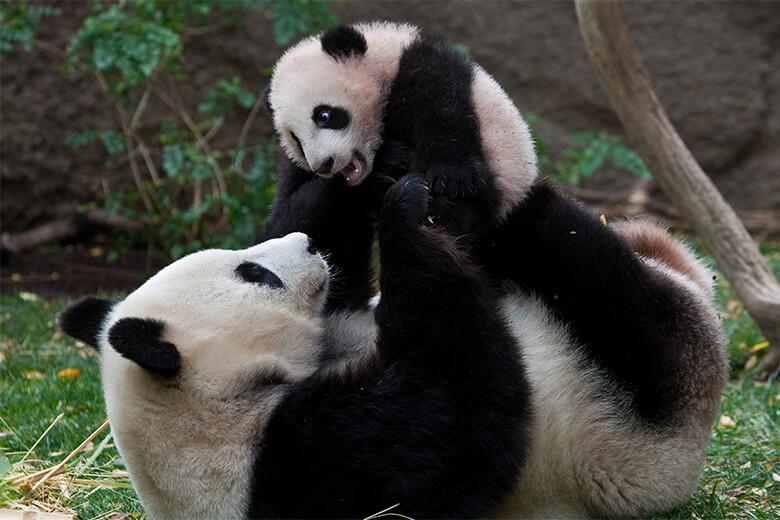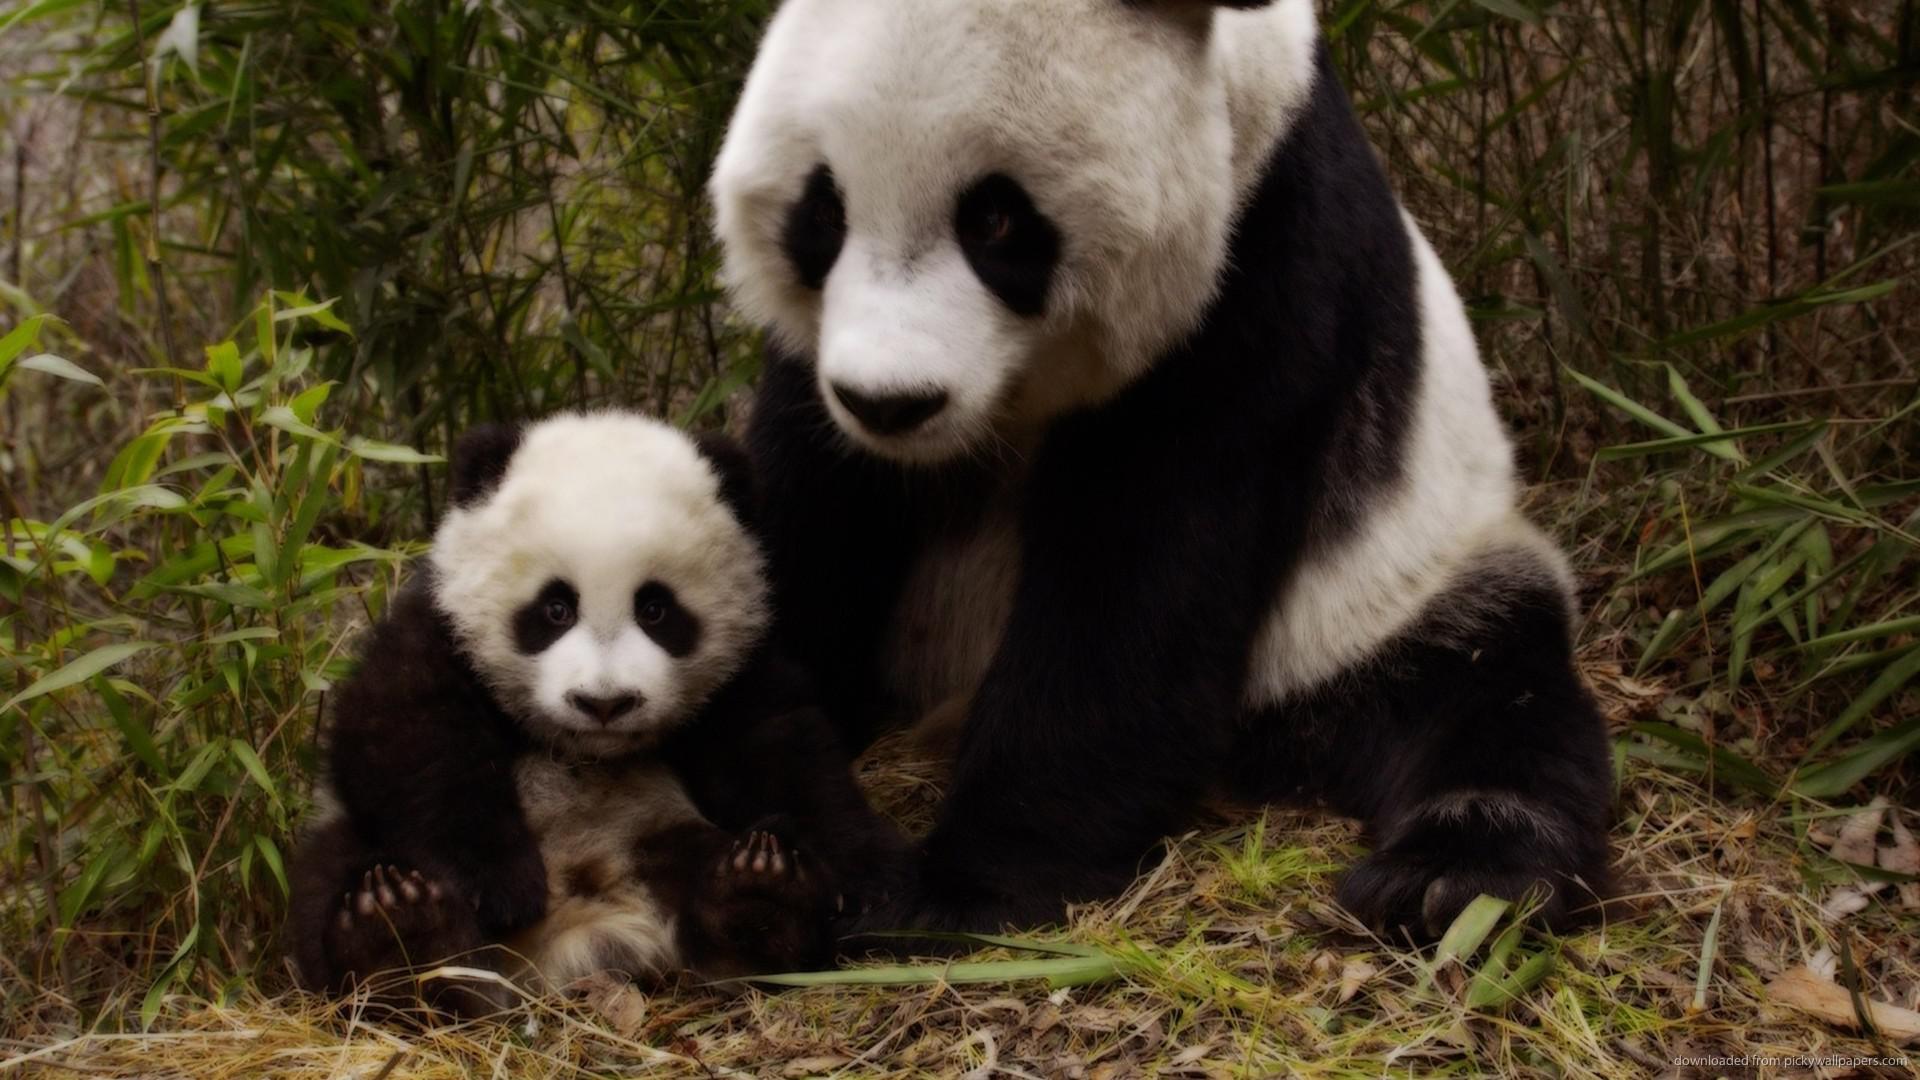The first image is the image on the left, the second image is the image on the right. Examine the images to the left and right. Is the description "A single panda is in one image with its mouth open, showing the pink interior and some teeth." accurate? Answer yes or no. No. The first image is the image on the left, the second image is the image on the right. Evaluate the accuracy of this statement regarding the images: "An image shows exactly one panda, and it has an opened mouth.". Is it true? Answer yes or no. No. 